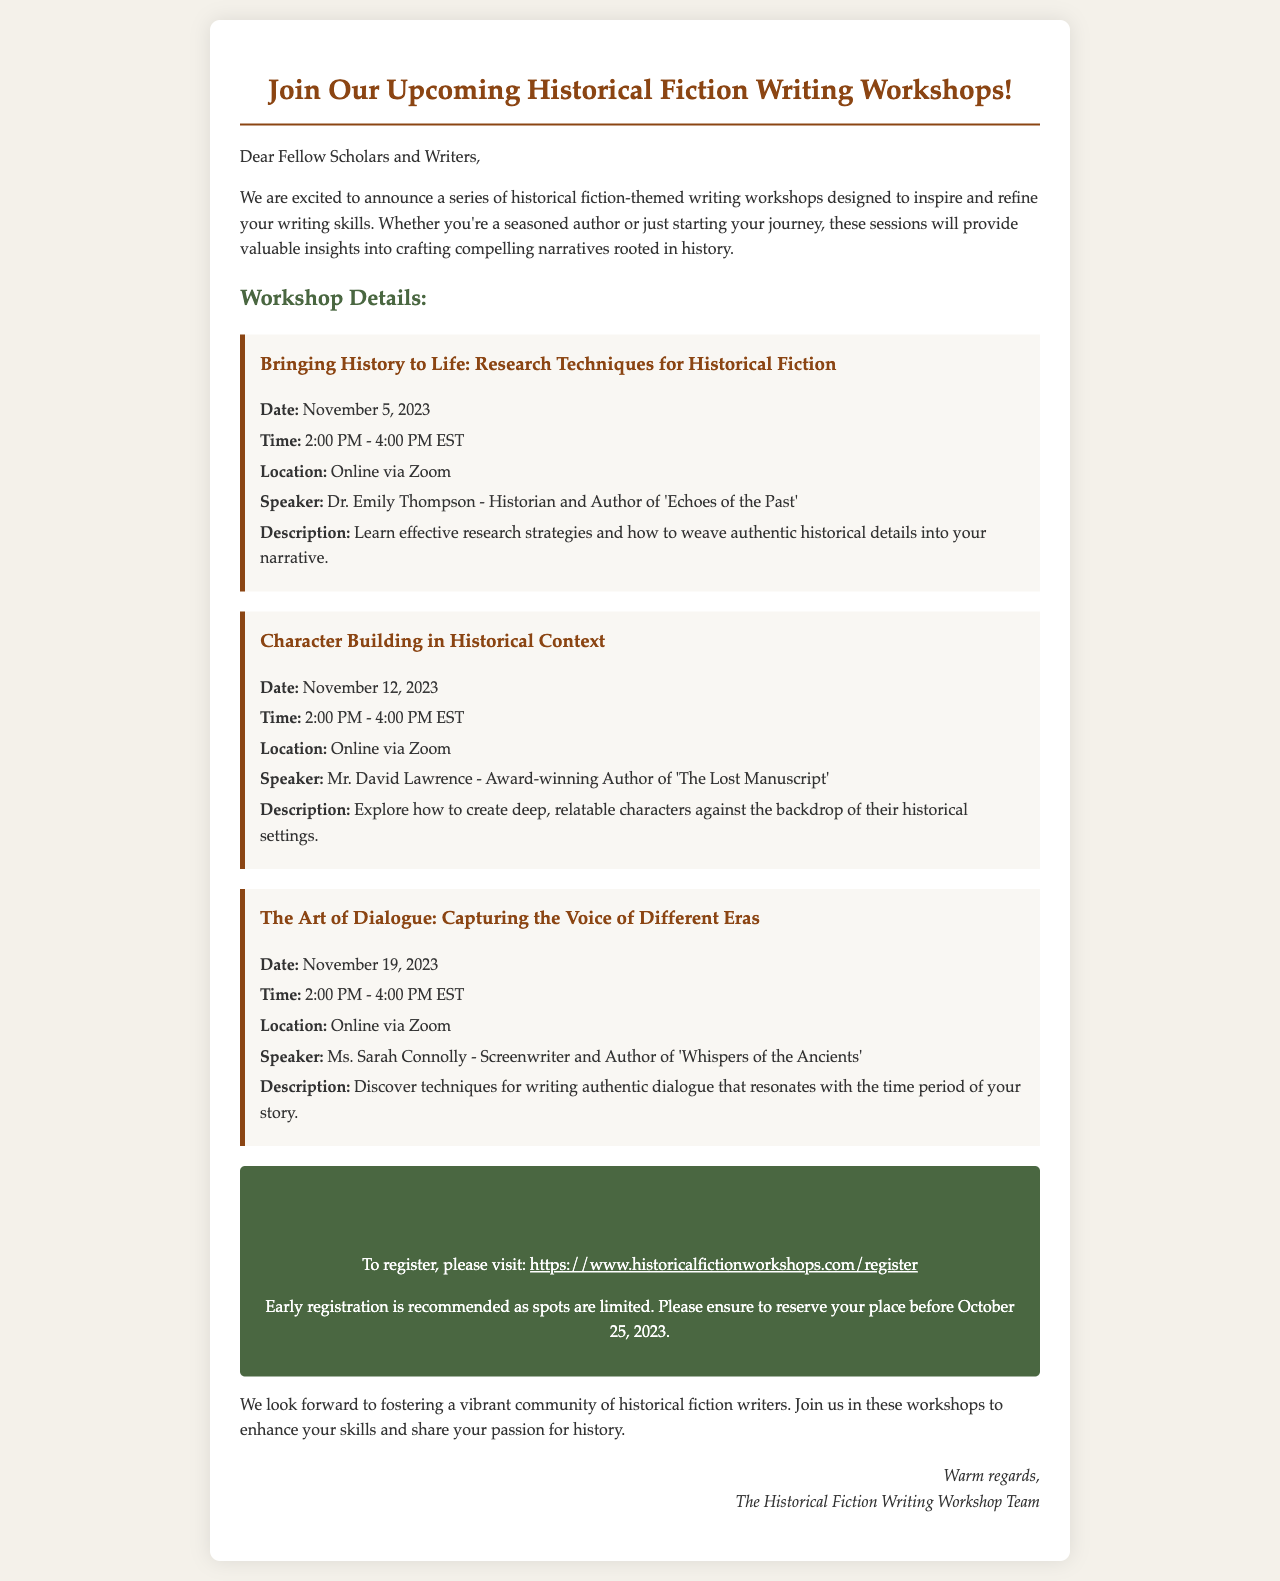What is the date of the first workshop? The date of the first workshop is explicitly mentioned in the document.
Answer: November 5, 2023 Who is the speaker for the second workshop? The document provides the name of the speaker for each workshop.
Answer: Mr. David Lawrence What is the time duration for each workshop? Each workshop's time duration is consistently mentioned in the document.
Answer: 2:00 PM - 4:00 PM EST What is the registration deadline? The deadline is specifically noted in the registration information section.
Answer: October 25, 2023 Which workshop focuses on dialogue? The titles of the workshops reflect their main themes, allowing us to identify the one about dialogue.
Answer: The Art of Dialogue: Capturing the Voice of Different Eras How many workshops are listed in the document? The document states the separate workshops, allowing for quick counting.
Answer: Three workshops What is the primary topic of the first workshop? The title of the first workshop indicates its main focus area.
Answer: Research Techniques for Historical Fiction What is the website for registration? The registration information section provides the website clearly.
Answer: https://www.historicalfictionworkshops.com/register 